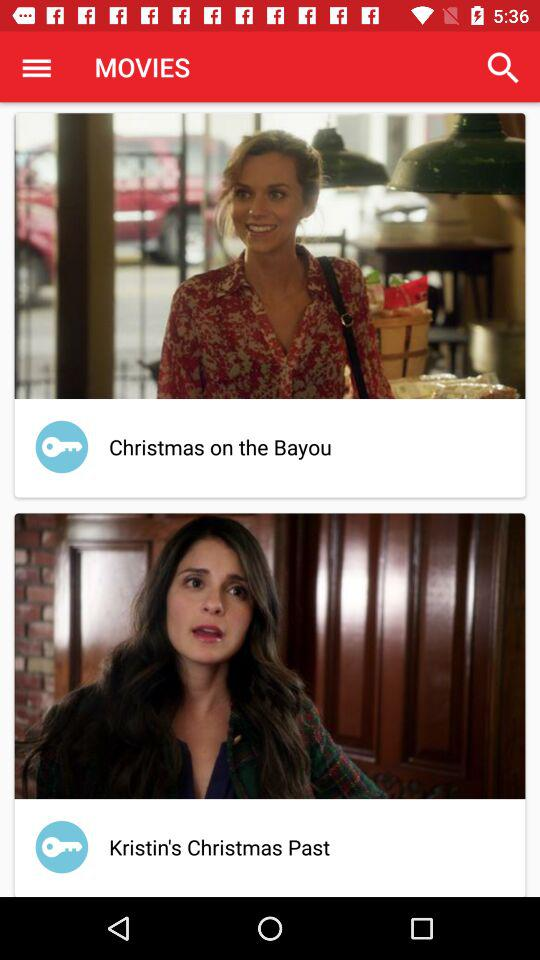Which movie has a longer title, Christmas on the Bayou or Kristin's Christmas Past?
Answer the question using a single word or phrase. Kristin's Christmas Past 